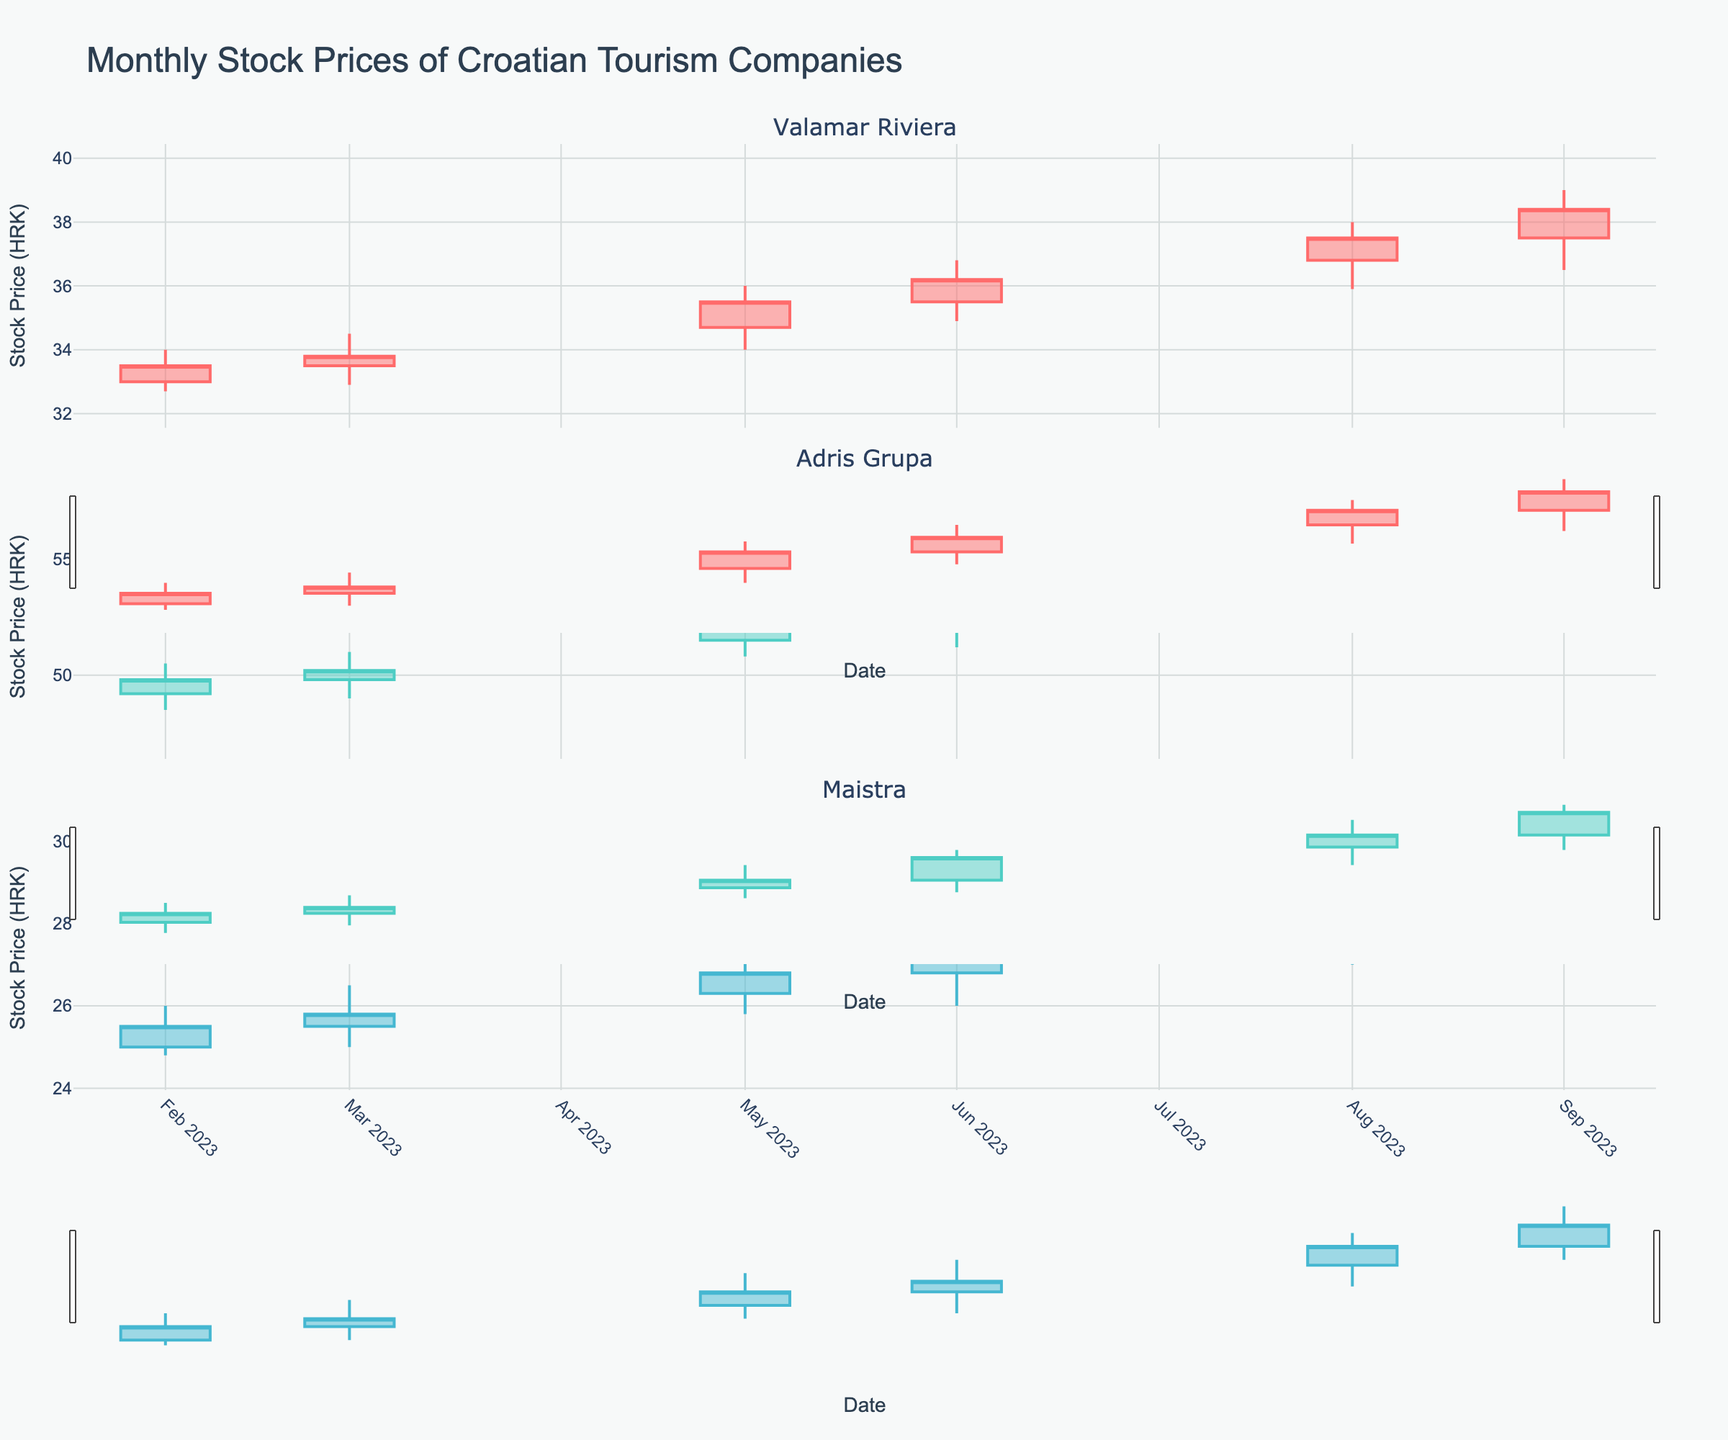What's the title of the figure? The title is located at the top of the figure. By looking at this part of the figure, you can find the title.
Answer: Monthly Stock Prices of Croatian Tourism Companies How many subplots are there in the figure? The figure includes subplots generated for each unique company in the dataset. To count them, simply identify the number of distinct rows, each representing a company.
Answer: 3 Which company had the highest closing stock price in October 2023? To find this, navigate to the October 2023 portion of the figure and compare the closing prices for each company.
Answer: Adris Grupa By how much did Valamar Riviera's stock price increase from January to October 2023? Locate Valamar Riviera's closing stock prices for January (33.0 HRK) and October (39.2 HRK), then calculate the difference between the two values.
Answer: 6.2 HRK Which month showed the highest volatility for Maistra, considering the range between the highest and lowest prices? For each month, compute the difference between the high and low prices for Maistra. Compare these differences to find the month with the maximum range.
Answer: September 2023 Was there any month where Adris Grupa's stock price closed lower than its opening price? Check Adris Grupa's candlesticks for each month. A month where the closing price is lower than the opening price will have the body of the candlestick colored differently (if applicable).
Answer: No Compare the closing prices of Valamar Riviera and Maistra in August 2023. Which one was higher? Look at the candlesticks for August 2023 and compare the closing prices of Valamar Riviera and Maistra.
Answer: Valamar Riviera What was the trend of Valamar Riviera's stock price over the observed period from January to October 2023? Examine the closing prices of Valamar Riviera month by month to identify if the trend was upward, downward, or stable.
Answer: Upward What is the average closing price of Adris Grupa over the 10-month period? Sum the closing prices of Adris Grupa for each month and divide by the number of months (10) to get the average.
Answer: 52.5 HRK During which months did Maistra's stock price close at exactly or highest compared to other months in 2023? Locate the months where Maistra's closing price is at its highest and check if it occurs in multiple months.
Answer: October 2023 